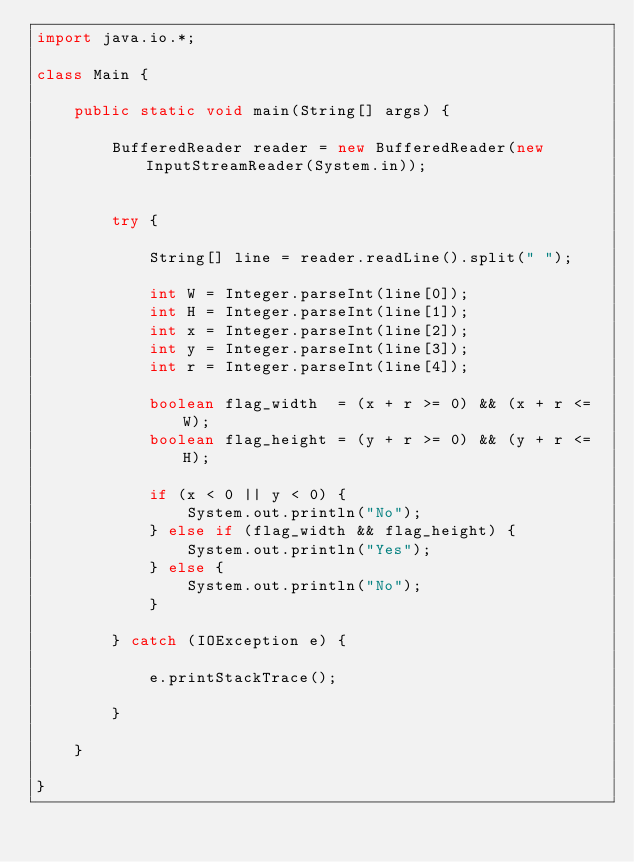<code> <loc_0><loc_0><loc_500><loc_500><_Java_>import java.io.*;

class Main {

    public static void main(String[] args) {

        BufferedReader reader = new BufferedReader(new InputStreamReader(System.in));

        
        try {

            String[] line = reader.readLine().split(" ");

            int W = Integer.parseInt(line[0]);
            int H = Integer.parseInt(line[1]);
            int x = Integer.parseInt(line[2]);
            int y = Integer.parseInt(line[3]);
            int r = Integer.parseInt(line[4]);
            
            boolean flag_width  = (x + r >= 0) && (x + r <= W);
            boolean flag_height = (y + r >= 0) && (y + r <= H);
            
            if (x < 0 || y < 0) { 
                System.out.println("No");
            } else if (flag_width && flag_height) {
                System.out.println("Yes");
            } else {
                System.out.println("No");
            }

        } catch (IOException e) {

            e.printStackTrace();

        }

    }

}</code> 